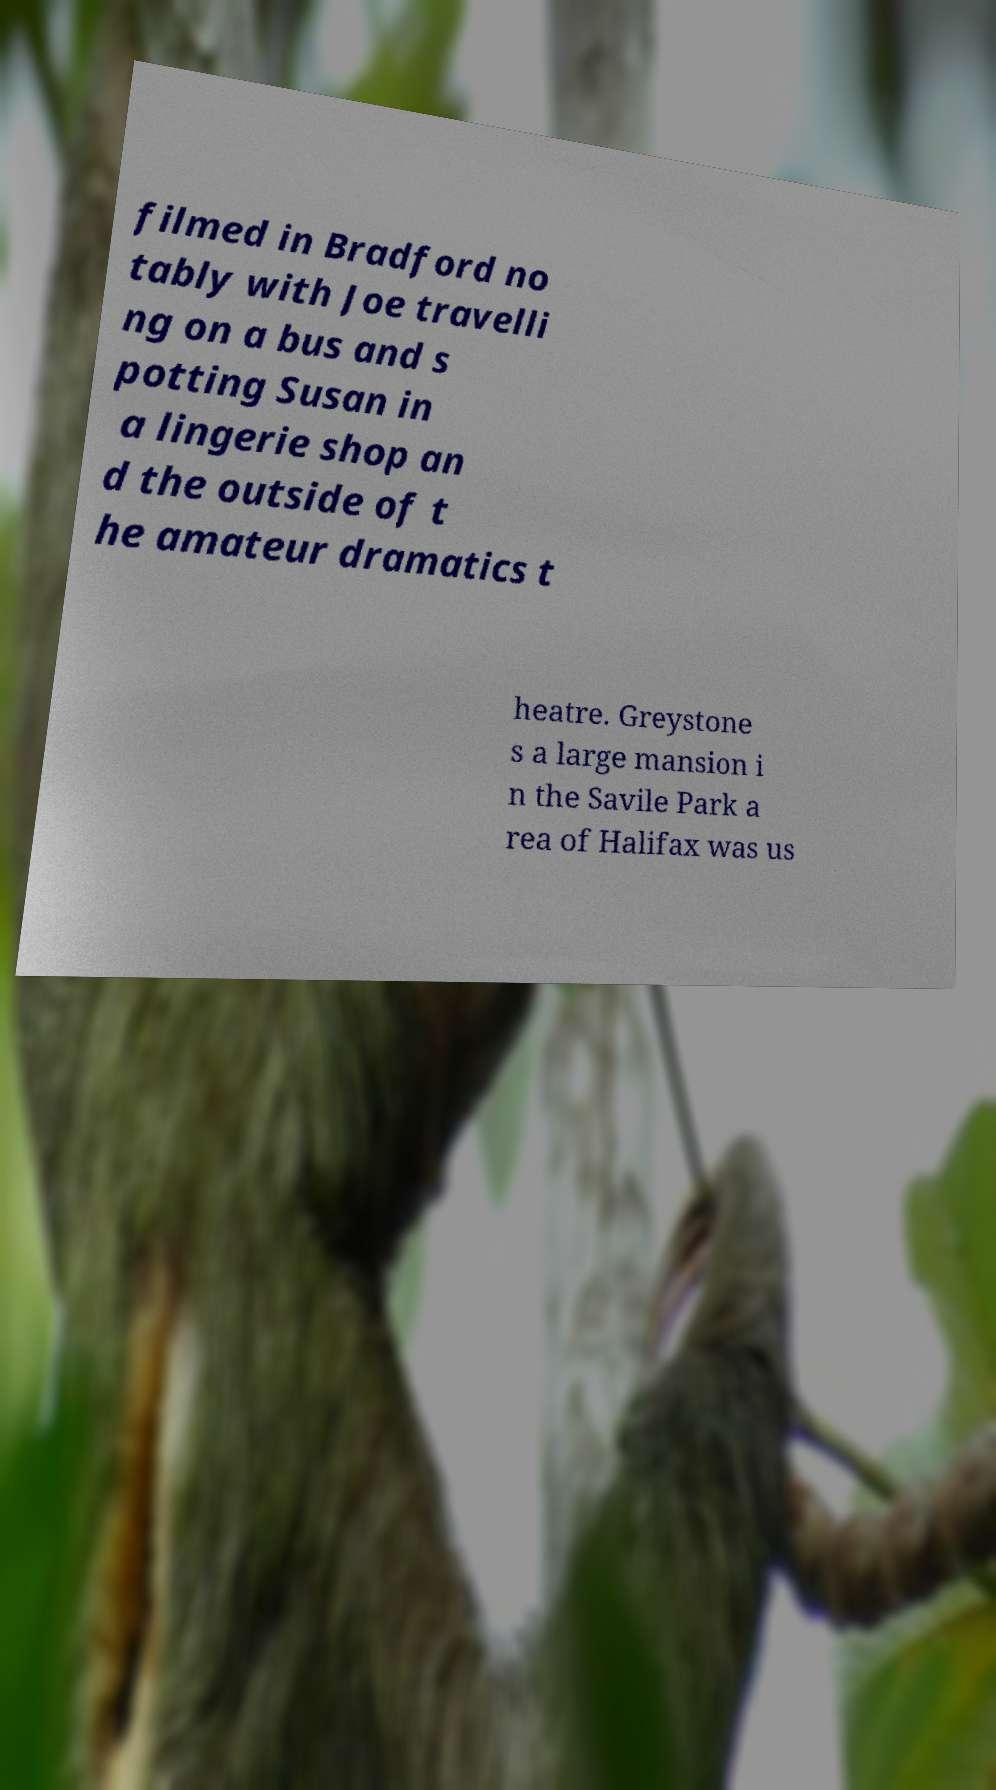There's text embedded in this image that I need extracted. Can you transcribe it verbatim? filmed in Bradford no tably with Joe travelli ng on a bus and s potting Susan in a lingerie shop an d the outside of t he amateur dramatics t heatre. Greystone s a large mansion i n the Savile Park a rea of Halifax was us 